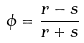<formula> <loc_0><loc_0><loc_500><loc_500>\phi = \frac { r - s } { r + s }</formula> 